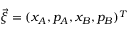<formula> <loc_0><loc_0><loc_500><loc_500>\vec { \xi } = ( x _ { A } , p _ { A } , x _ { B } , p _ { B } ) ^ { T }</formula> 